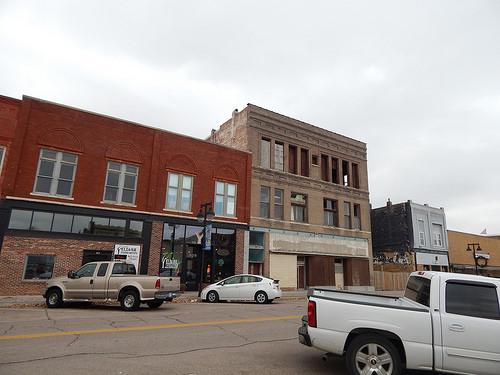<image>
Can you confirm if the truck is under the window? No. The truck is not positioned under the window. The vertical relationship between these objects is different. Is the building behind the car? Yes. From this viewpoint, the building is positioned behind the car, with the car partially or fully occluding the building. 